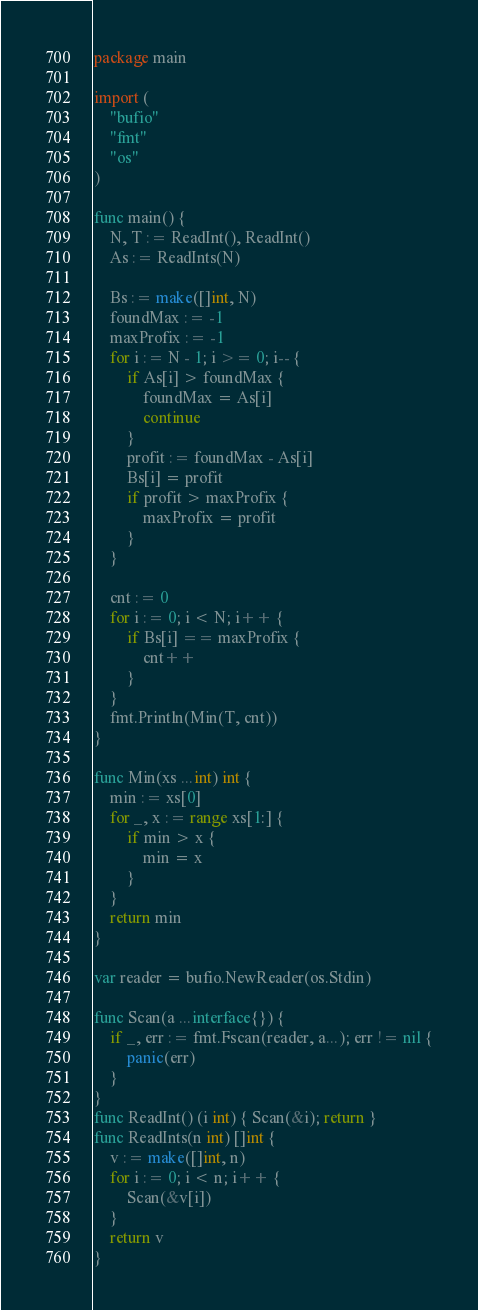<code> <loc_0><loc_0><loc_500><loc_500><_Go_>package main

import (
	"bufio"
	"fmt"
	"os"
)

func main() {
	N, T := ReadInt(), ReadInt()
	As := ReadInts(N)

	Bs := make([]int, N)
	foundMax := -1
	maxProfix := -1
	for i := N - 1; i >= 0; i-- {
		if As[i] > foundMax {
			foundMax = As[i]
			continue
		}
		profit := foundMax - As[i]
		Bs[i] = profit
		if profit > maxProfix {
			maxProfix = profit
		}
	}

	cnt := 0
	for i := 0; i < N; i++ {
		if Bs[i] == maxProfix {
			cnt++
		}
	}
	fmt.Println(Min(T, cnt))
}

func Min(xs ...int) int {
	min := xs[0]
	for _, x := range xs[1:] {
		if min > x {
			min = x
		}
	}
	return min
}

var reader = bufio.NewReader(os.Stdin)

func Scan(a ...interface{}) {
	if _, err := fmt.Fscan(reader, a...); err != nil {
		panic(err)
	}
}
func ReadInt() (i int) { Scan(&i); return }
func ReadInts(n int) []int {
	v := make([]int, n)
	for i := 0; i < n; i++ {
		Scan(&v[i])
	}
	return v
}
</code> 